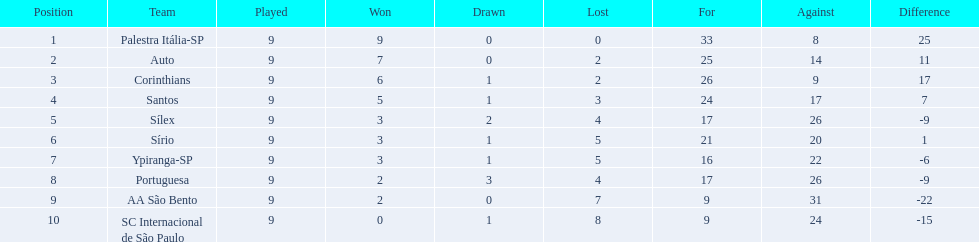How many points were scored by the teams? 18, 14, 13, 11, 8, 7, 7, 7, 4, 1. What team scored 13 points? Corinthians. 